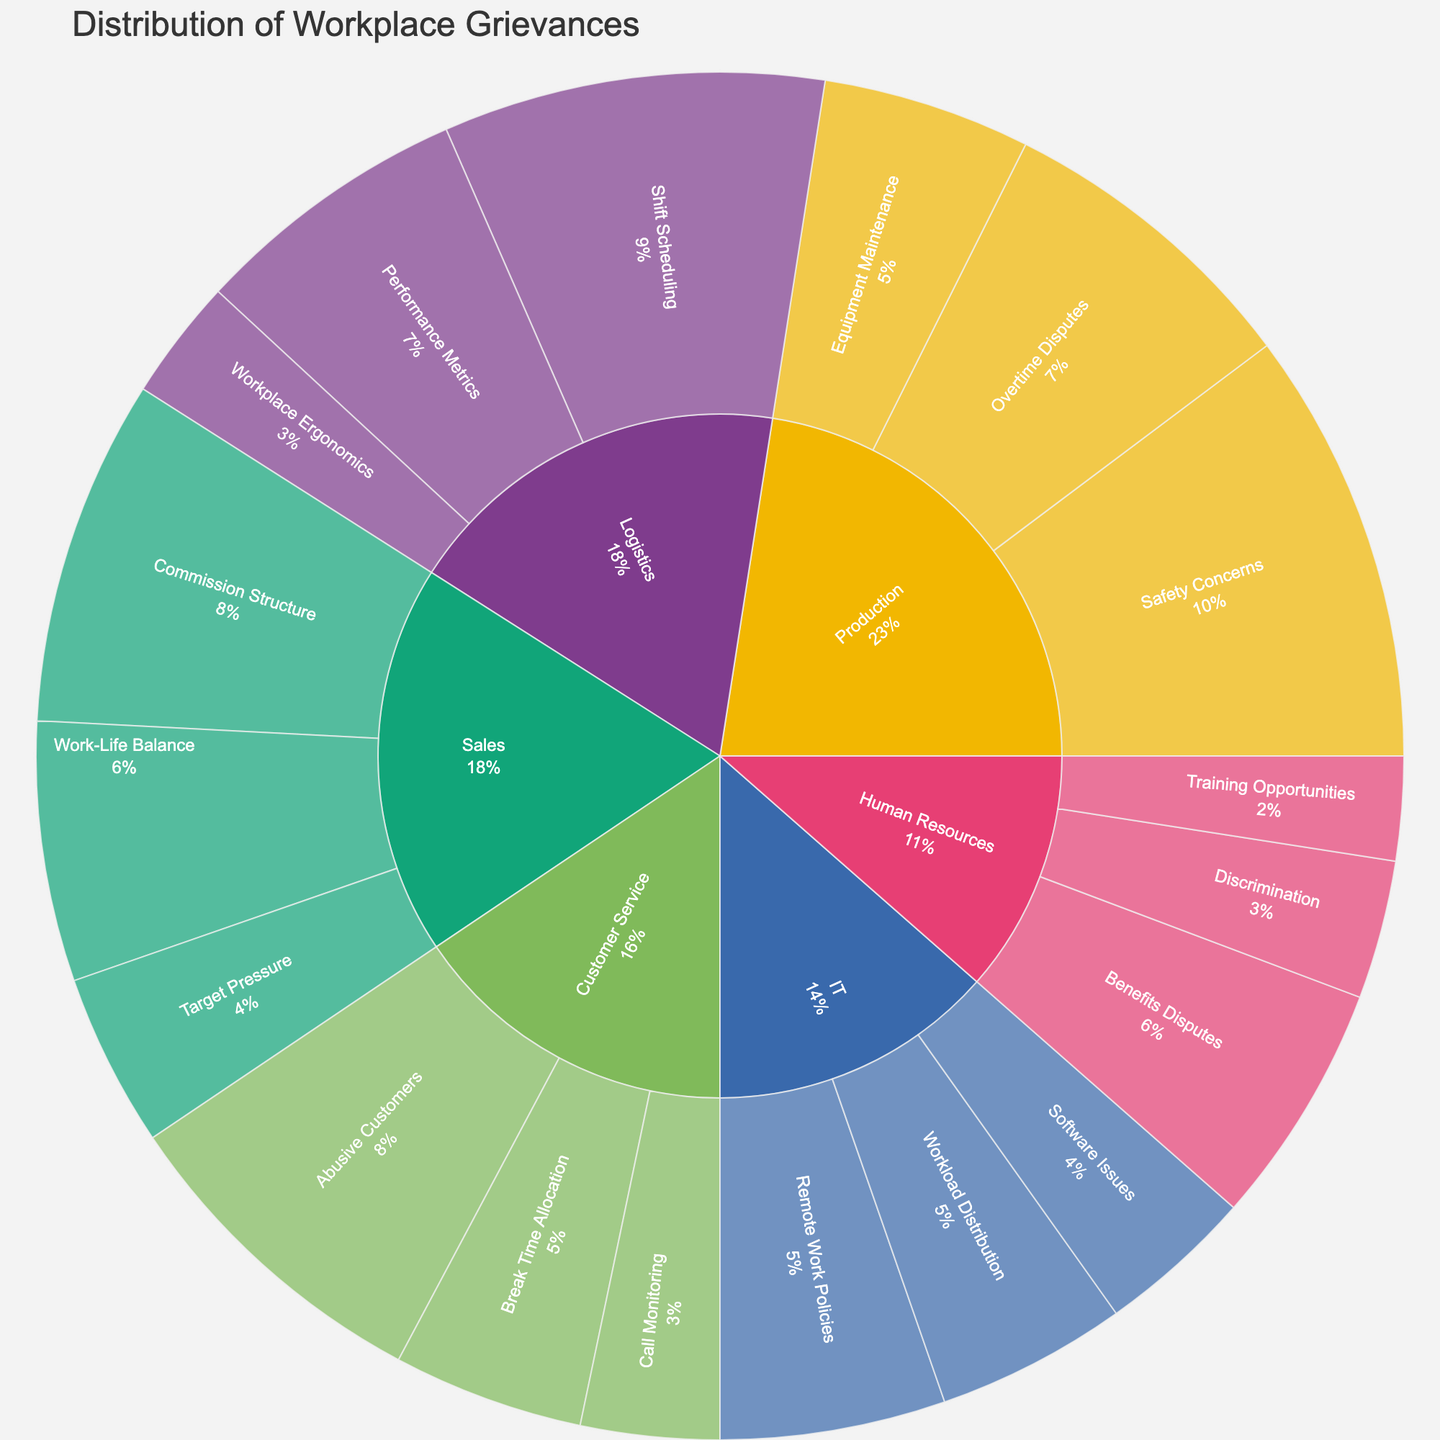Which department has the most grievances? The largest section in the sunburst plot represents the department with the highest number of grievances. In this case, it is the Production department.
Answer: Production How many grievances does the Sales department have in total? Add up the grievance counts in the Sales department: Commission Structure (20) + Work-Life Balance (15) + Target Pressure (10) = 45.
Answer: 45 What percentage of the total grievances does the "Safety Concerns" issue in the Production department represent? Identify the count for "Safety Concerns" in the Production department, which is 25, then sum all grievances to find the total: 245. Calculate the percentage: (25 / 245) * 100 ≈ 10.2%.
Answer: 10.2% Which issue type in the Logistics department has the highest number of grievances? By comparing the different issue types within the Logistics segment of the sunburst plot, Shift Scheduling has the highest count at 22.
Answer: Shift Scheduling Are there more grievances related to "Overtime Disputes" in Production or "Target Pressure" in Sales? Compare the counts of the two grievances: Overtime Disputes in Production = 18 and Target Pressure in Sales = 10. Overtime Disputes has more grievances.
Answer: Overtime Disputes in Production What is the combined number of grievances for "Software Issues" and "Remote Work Policies" in the IT department? Add the counts for Software Issues (9) and Remote Work Policies (13) in the IT department: 9 + 13 = 22.
Answer: 22 How does the number of grievances regarding "Discrimination" in Human Resources compare to "Abusive Customers" in Customer Service? Compare the grievance counts: Discrimination in Human Resources = 8, Abusive Customers in Customer Service = 19. Abusive Customers has more grievances.
Answer: Abusive Customers in Customer Service What's the average number of grievances per issue type in the Customer Service department? Add up the grievances in Customer Service: Abusive Customers (19) + Call Monitoring (8) + Break Time Allocation (11) = 38. Divide by the number of issue types (3): 38 / 3 ≈ 12.67.
Answer: 12.67 Which issue type has the lowest count in the entire dataset? Identify the smallest segment on the sunburst plot, which is Training Opportunities in Human Resources with a count of 6.
Answer: Training Opportunities in Human Resources How do the grievances in "Workload Distribution" in IT compare to those in "Equipment Maintenance" in Production? Compare the grievance counts: Workload Distribution in IT = 11, Equipment Maintenance in Production = 12. Equipment Maintenance has more grievances.
Answer: Equipment Maintenance in Production 